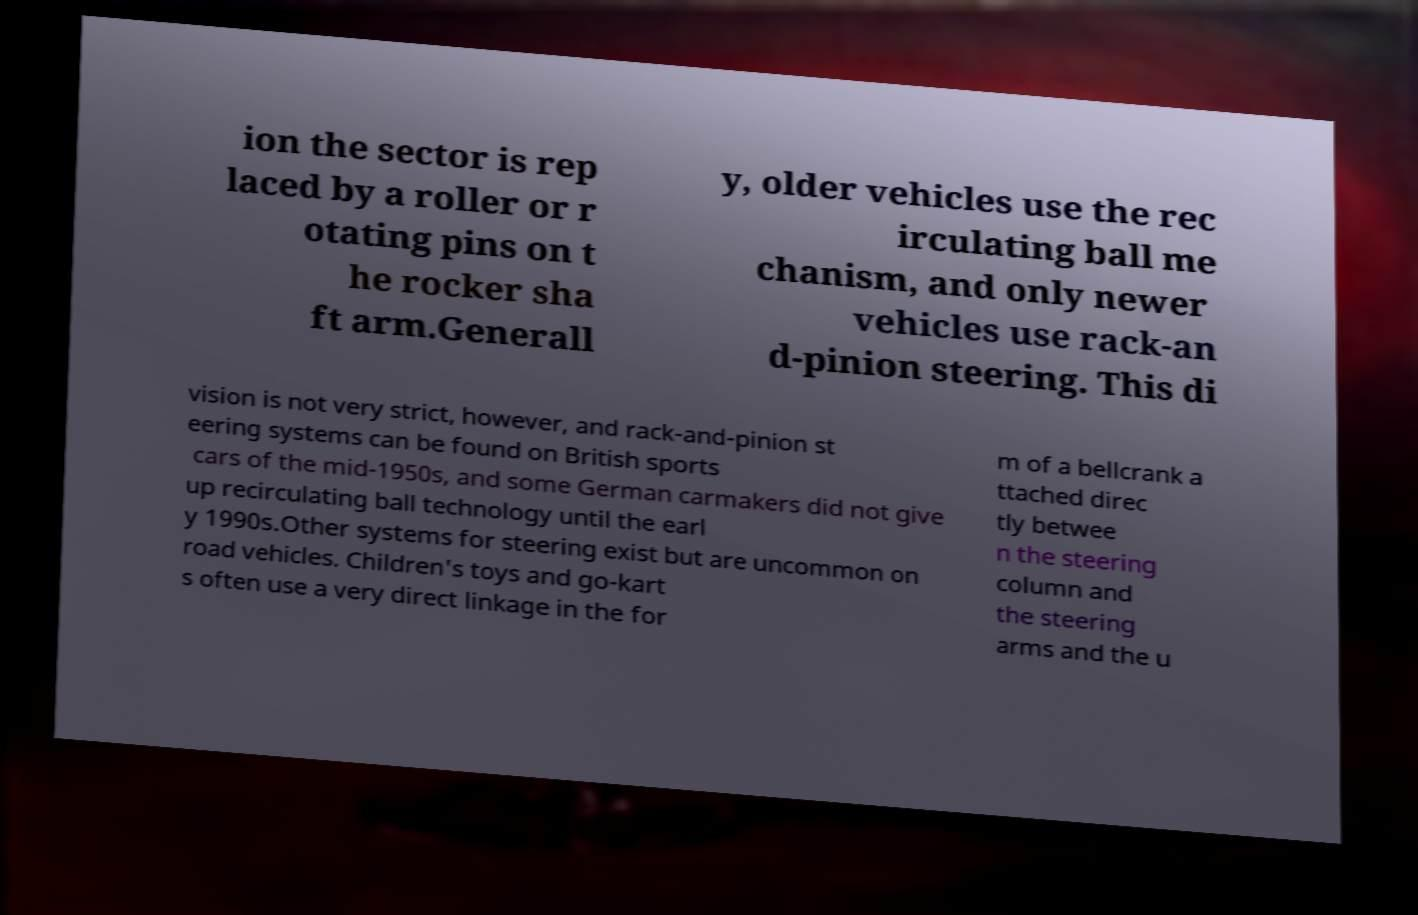I need the written content from this picture converted into text. Can you do that? ion the sector is rep laced by a roller or r otating pins on t he rocker sha ft arm.Generall y, older vehicles use the rec irculating ball me chanism, and only newer vehicles use rack-an d-pinion steering. This di vision is not very strict, however, and rack-and-pinion st eering systems can be found on British sports cars of the mid-1950s, and some German carmakers did not give up recirculating ball technology until the earl y 1990s.Other systems for steering exist but are uncommon on road vehicles. Children's toys and go-kart s often use a very direct linkage in the for m of a bellcrank a ttached direc tly betwee n the steering column and the steering arms and the u 